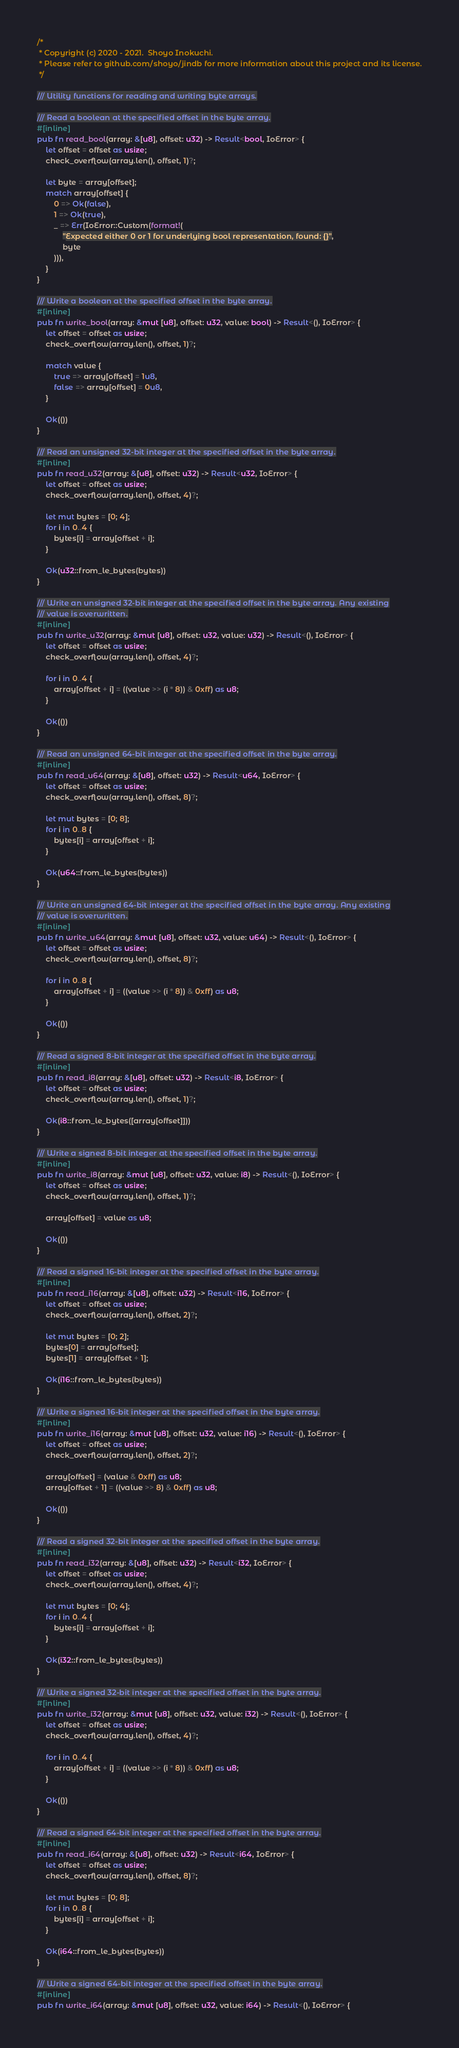Convert code to text. <code><loc_0><loc_0><loc_500><loc_500><_Rust_>/*
 * Copyright (c) 2020 - 2021.  Shoyo Inokuchi.
 * Please refer to github.com/shoyo/jindb for more information about this project and its license.
 */

/// Utility functions for reading and writing byte arrays.

/// Read a boolean at the specified offset in the byte array.
#[inline]
pub fn read_bool(array: &[u8], offset: u32) -> Result<bool, IoError> {
    let offset = offset as usize;
    check_overflow(array.len(), offset, 1)?;

    let byte = array[offset];
    match array[offset] {
        0 => Ok(false),
        1 => Ok(true),
        _ => Err(IoError::Custom(format!(
            "Expected either 0 or 1 for underlying bool representation, found: {}",
            byte
        ))),
    }
}

/// Write a boolean at the specified offset in the byte array.
#[inline]
pub fn write_bool(array: &mut [u8], offset: u32, value: bool) -> Result<(), IoError> {
    let offset = offset as usize;
    check_overflow(array.len(), offset, 1)?;

    match value {
        true => array[offset] = 1u8,
        false => array[offset] = 0u8,
    }

    Ok(())
}

/// Read an unsigned 32-bit integer at the specified offset in the byte array.
#[inline]
pub fn read_u32(array: &[u8], offset: u32) -> Result<u32, IoError> {
    let offset = offset as usize;
    check_overflow(array.len(), offset, 4)?;

    let mut bytes = [0; 4];
    for i in 0..4 {
        bytes[i] = array[offset + i];
    }

    Ok(u32::from_le_bytes(bytes))
}

/// Write an unsigned 32-bit integer at the specified offset in the byte array. Any existing
/// value is overwritten.
#[inline]
pub fn write_u32(array: &mut [u8], offset: u32, value: u32) -> Result<(), IoError> {
    let offset = offset as usize;
    check_overflow(array.len(), offset, 4)?;

    for i in 0..4 {
        array[offset + i] = ((value >> (i * 8)) & 0xff) as u8;
    }

    Ok(())
}

/// Read an unsigned 64-bit integer at the specified offset in the byte array.
#[inline]
pub fn read_u64(array: &[u8], offset: u32) -> Result<u64, IoError> {
    let offset = offset as usize;
    check_overflow(array.len(), offset, 8)?;

    let mut bytes = [0; 8];
    for i in 0..8 {
        bytes[i] = array[offset + i];
    }

    Ok(u64::from_le_bytes(bytes))
}

/// Write an unsigned 64-bit integer at the specified offset in the byte array. Any existing
/// value is overwritten.
#[inline]
pub fn write_u64(array: &mut [u8], offset: u32, value: u64) -> Result<(), IoError> {
    let offset = offset as usize;
    check_overflow(array.len(), offset, 8)?;

    for i in 0..8 {
        array[offset + i] = ((value >> (i * 8)) & 0xff) as u8;
    }

    Ok(())
}

/// Read a signed 8-bit integer at the specified offset in the byte array.
#[inline]
pub fn read_i8(array: &[u8], offset: u32) -> Result<i8, IoError> {
    let offset = offset as usize;
    check_overflow(array.len(), offset, 1)?;

    Ok(i8::from_le_bytes([array[offset]]))
}

/// Write a signed 8-bit integer at the specified offset in the byte array.
#[inline]
pub fn write_i8(array: &mut [u8], offset: u32, value: i8) -> Result<(), IoError> {
    let offset = offset as usize;
    check_overflow(array.len(), offset, 1)?;

    array[offset] = value as u8;

    Ok(())
}

/// Read a signed 16-bit integer at the specified offset in the byte array.
#[inline]
pub fn read_i16(array: &[u8], offset: u32) -> Result<i16, IoError> {
    let offset = offset as usize;
    check_overflow(array.len(), offset, 2)?;

    let mut bytes = [0; 2];
    bytes[0] = array[offset];
    bytes[1] = array[offset + 1];

    Ok(i16::from_le_bytes(bytes))
}

/// Write a signed 16-bit integer at the specified offset in the byte array.
#[inline]
pub fn write_i16(array: &mut [u8], offset: u32, value: i16) -> Result<(), IoError> {
    let offset = offset as usize;
    check_overflow(array.len(), offset, 2)?;

    array[offset] = (value & 0xff) as u8;
    array[offset + 1] = ((value >> 8) & 0xff) as u8;

    Ok(())
}

/// Read a signed 32-bit integer at the specified offset in the byte array.
#[inline]
pub fn read_i32(array: &[u8], offset: u32) -> Result<i32, IoError> {
    let offset = offset as usize;
    check_overflow(array.len(), offset, 4)?;

    let mut bytes = [0; 4];
    for i in 0..4 {
        bytes[i] = array[offset + i];
    }

    Ok(i32::from_le_bytes(bytes))
}

/// Write a signed 32-bit integer at the specified offset in the byte array.
#[inline]
pub fn write_i32(array: &mut [u8], offset: u32, value: i32) -> Result<(), IoError> {
    let offset = offset as usize;
    check_overflow(array.len(), offset, 4)?;

    for i in 0..4 {
        array[offset + i] = ((value >> (i * 8)) & 0xff) as u8;
    }

    Ok(())
}

/// Read a signed 64-bit integer at the specified offset in the byte array.
#[inline]
pub fn read_i64(array: &[u8], offset: u32) -> Result<i64, IoError> {
    let offset = offset as usize;
    check_overflow(array.len(), offset, 8)?;

    let mut bytes = [0; 8];
    for i in 0..8 {
        bytes[i] = array[offset + i];
    }

    Ok(i64::from_le_bytes(bytes))
}

/// Write a signed 64-bit integer at the specified offset in the byte array.
#[inline]
pub fn write_i64(array: &mut [u8], offset: u32, value: i64) -> Result<(), IoError> {</code> 